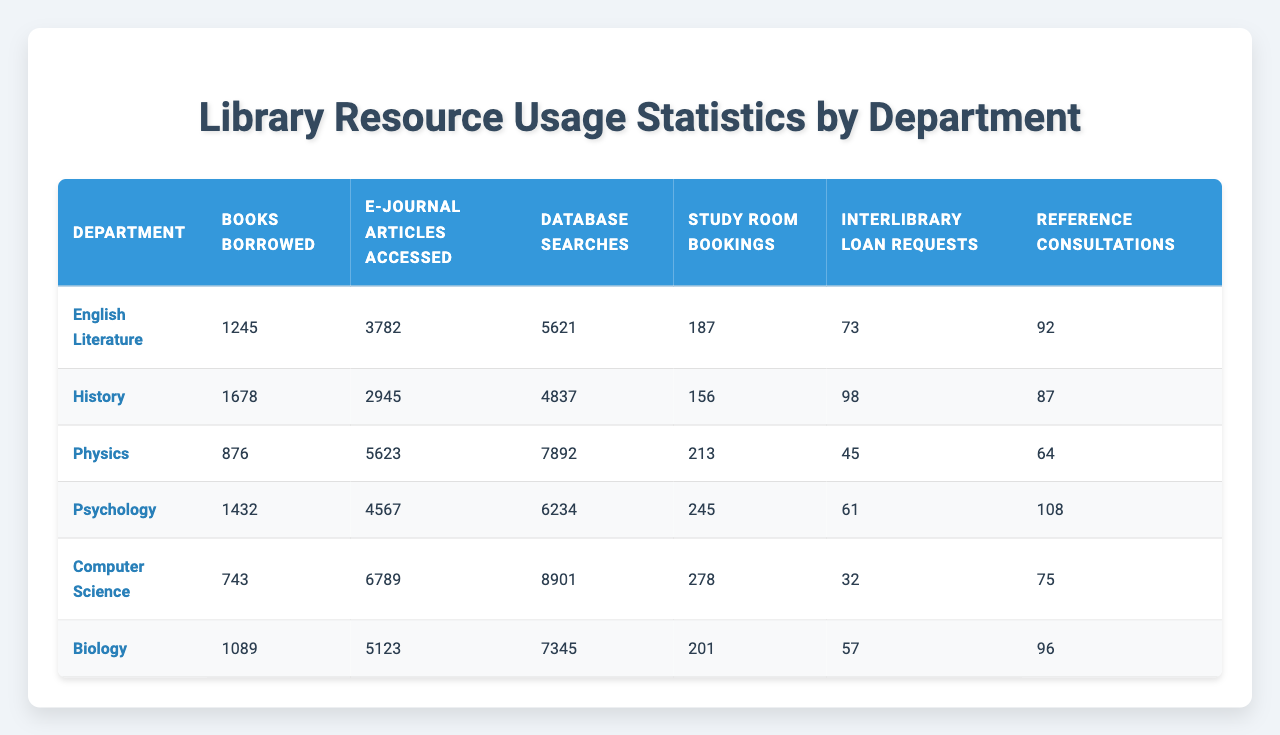What is the total number of books borrowed by all departments combined? By adding the books borrowed by each department: 1245 (English Literature) + 1678 (History) + 876 (Physics) + 1432 (Psychology) + 743 (Computer Science) + 1089 (Biology) = 6263
Answer: 6263 Which department accessed the highest number of E-Journal articles? Looking through the E-Journal articles accessed: English Literature (3782), History (2945), Physics (5623), Psychology (4567), Computer Science (6789), and Biology (5123), Computer Science has the highest at 6789.
Answer: Computer Science How many Study Room bookings did the Psychology department make? Directly referencing the table, the Psychology department made a total of 245 Study Room bookings.
Answer: 245 What is the average number of Interlibrary Loan Requests across all departments? Summing the requests: 73 (English Literature) + 98 (History) + 45 (Physics) + 61 (Psychology) + 32 (Computer Science) + 57 (Biology) = 366. Dividing by the number of departments, which is 6: 366 / 6 = 61.
Answer: 61 Did the Physics department borrow more books than the English Literature department? The Physics department borrowed 876 books, while the English Literature department borrowed 1245 books. Since 876 is less than 1245, the statement is false.
Answer: No Which department had the lowest number of Database Searches? Checking each department's Database Searches: English Literature (5621), History (4837), Physics (7892), Psychology (6234), Computer Science (8901), and Biology (7345). History had the lowest number with 4837.
Answer: History What is the total number of Reference Consultations made by the Psychology and Biology departments combined? Adding the Reference Consultations for both: 108 (Psychology) + 96 (Biology) = 204.
Answer: 204 Which department had the highest number of Study Room Bookings? Comparing each department's Study Room bookings: English Literature (187), History (156), Physics (213), Psychology (245), Computer Science (278), and Biology (201), Computer Science has the highest with 278.
Answer: Computer Science How many more E-Journal articles did the Computer Science department access compared to the Biology department? For E-Journal articles accessed: Computer Science (6789) minus Biology (5123) gives 6789 - 5123 = 1666.
Answer: 1666 Which department used reference consultations the least? Comparing the Reference Consultations: 92 (English Literature), 87 (History), 64 (Physics), 108 (Psychology), 75 (Computer Science), and 96 (Biology), the Physics department had the least with 64 consultations.
Answer: Physics 